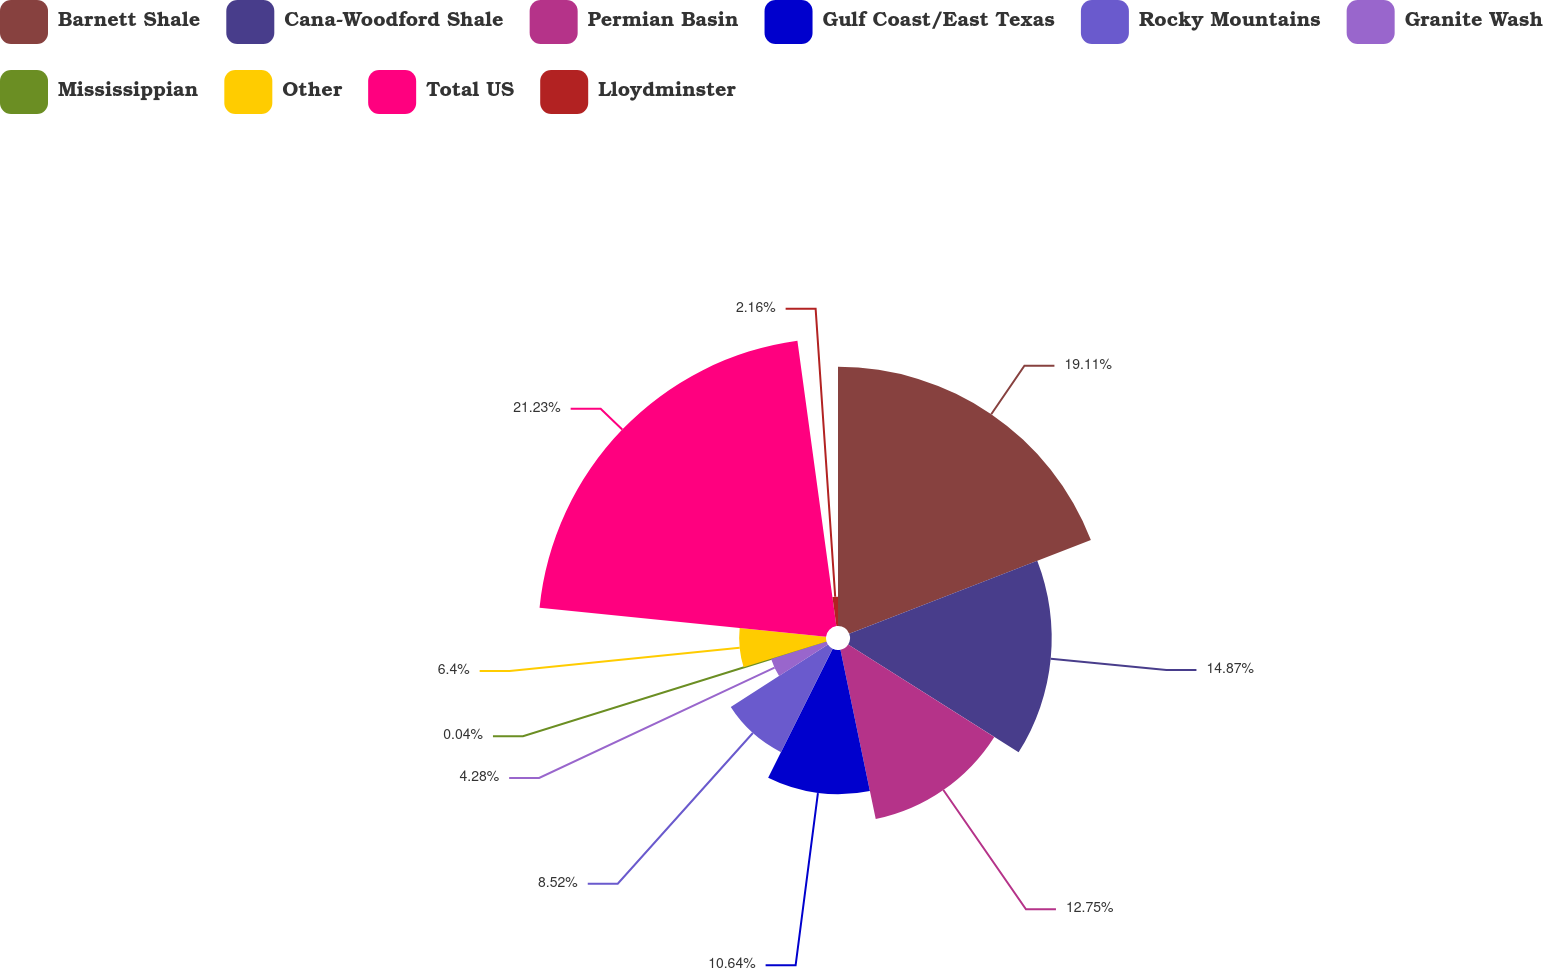<chart> <loc_0><loc_0><loc_500><loc_500><pie_chart><fcel>Barnett Shale<fcel>Cana-Woodford Shale<fcel>Permian Basin<fcel>Gulf Coast/East Texas<fcel>Rocky Mountains<fcel>Granite Wash<fcel>Mississippian<fcel>Other<fcel>Total US<fcel>Lloydminster<nl><fcel>19.11%<fcel>14.87%<fcel>12.75%<fcel>10.64%<fcel>8.52%<fcel>4.28%<fcel>0.04%<fcel>6.4%<fcel>21.23%<fcel>2.16%<nl></chart> 